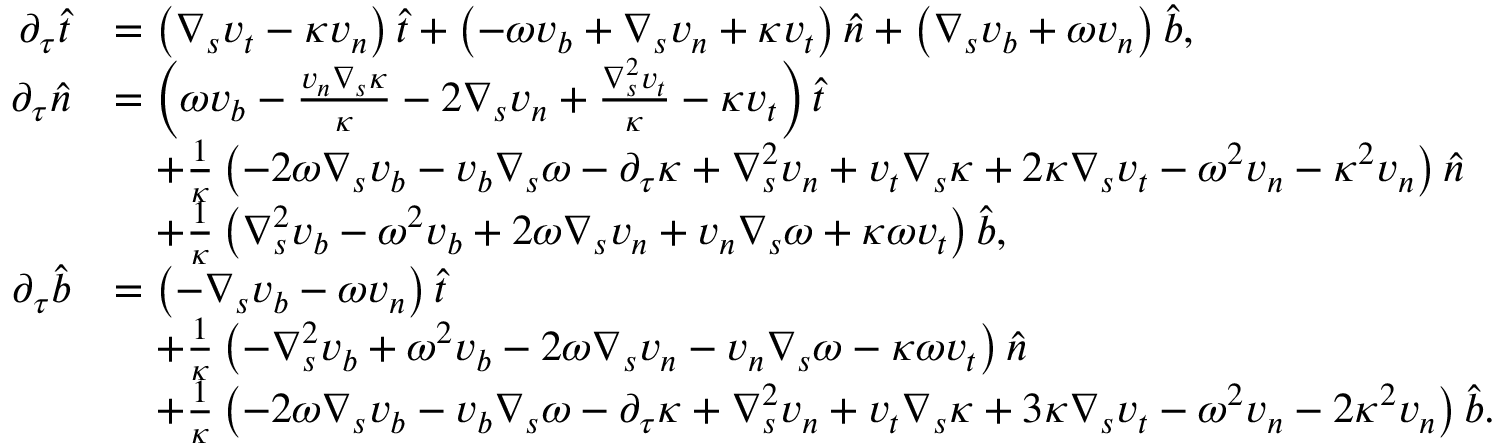<formula> <loc_0><loc_0><loc_500><loc_500>\begin{array} { r l } { \partial _ { \tau } \widehat { t } } & { = \left ( \nabla _ { s } v _ { t } - \kappa v _ { n } \right ) \widehat { t } + \left ( - \omega v _ { b } + \nabla _ { s } v _ { n } + \kappa v _ { t } \right ) \widehat { n } + \left ( \nabla _ { s } v _ { b } + \omega v _ { n } \right ) \widehat { b } , } \\ { \partial _ { \tau } \widehat { n } } & { = \left ( \omega v _ { b } - \frac { v _ { n } \nabla _ { s } \kappa } { \kappa } - 2 \nabla _ { s } v _ { n } + \frac { \nabla _ { s } ^ { 2 } v _ { t } } { \kappa } - \kappa v _ { t } \right ) \widehat { t } } \\ & { \quad + \frac { 1 } { \kappa } \left ( - { 2 \omega \nabla _ { s } v _ { b } } - { v _ { b } \nabla _ { s } \omega } - { \partial _ { \tau } \kappa } + { \nabla _ { s } ^ { 2 } v _ { n } } + { v _ { t } \nabla _ { s } \kappa } + 2 \kappa \nabla _ { s } v _ { t } - { \omega ^ { 2 } v _ { n } } - \kappa ^ { 2 } v _ { n } \right ) \widehat { n } } \\ & { \quad + \frac { 1 } { \kappa } \left ( { \nabla _ { s } ^ { 2 } v _ { b } } - { \omega ^ { 2 } v _ { b } } + { 2 \omega \nabla _ { s } v _ { n } } + { v _ { n } \nabla _ { s } \omega } + \kappa \omega v _ { t } \right ) \widehat { b } , } \\ { \partial _ { \tau } \widehat { b } } & { = \left ( - \nabla _ { s } v _ { b } - \omega v _ { n } \right ) \widehat { t } } \\ & { \quad + \frac { 1 } { \kappa } \left ( - { \nabla _ { s } ^ { 2 } v _ { b } } + { \omega ^ { 2 } v _ { b } } - { 2 \omega \nabla _ { s } v _ { n } } - { v _ { n } \nabla _ { s } \omega } - \kappa \omega v _ { t } \right ) \widehat { n } } \\ & { \quad + \frac { 1 } { \kappa } \left ( - { 2 \omega \nabla _ { s } v _ { b } } - { v _ { b } \nabla _ { s } \omega } - { \partial _ { \tau } \kappa } + { \nabla _ { s } ^ { 2 } v _ { n } } + { v _ { t } \nabla _ { s } \kappa } + 3 \kappa \nabla _ { s } v _ { t } - { \omega ^ { 2 } v _ { n } } - 2 \kappa ^ { 2 } v _ { n } \right ) \widehat { b } . } \end{array}</formula> 